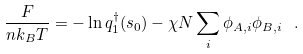<formula> <loc_0><loc_0><loc_500><loc_500>\frac { F } { n k _ { B } T } = - \ln q _ { 1 } ^ { \dag } ( s _ { 0 } ) - \chi N \sum _ { i } \phi _ { A , i } \phi _ { B , i } \ .</formula> 